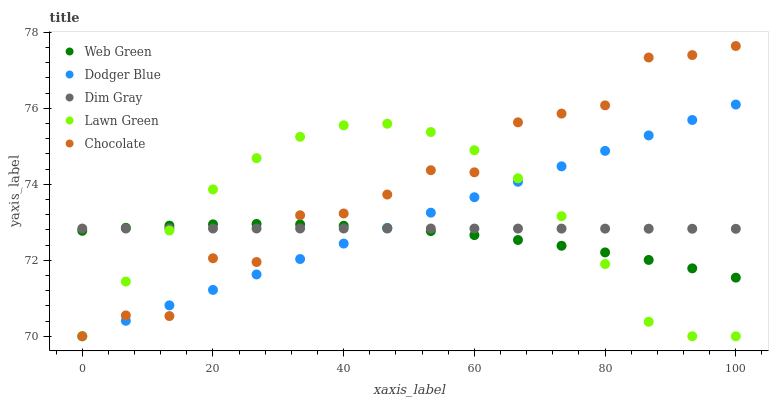Does Web Green have the minimum area under the curve?
Answer yes or no. Yes. Does Chocolate have the maximum area under the curve?
Answer yes or no. Yes. Does Dim Gray have the minimum area under the curve?
Answer yes or no. No. Does Dim Gray have the maximum area under the curve?
Answer yes or no. No. Is Dodger Blue the smoothest?
Answer yes or no. Yes. Is Chocolate the roughest?
Answer yes or no. Yes. Is Dim Gray the smoothest?
Answer yes or no. No. Is Dim Gray the roughest?
Answer yes or no. No. Does Lawn Green have the lowest value?
Answer yes or no. Yes. Does Dim Gray have the lowest value?
Answer yes or no. No. Does Chocolate have the highest value?
Answer yes or no. Yes. Does Dodger Blue have the highest value?
Answer yes or no. No. Does Lawn Green intersect Chocolate?
Answer yes or no. Yes. Is Lawn Green less than Chocolate?
Answer yes or no. No. Is Lawn Green greater than Chocolate?
Answer yes or no. No. 